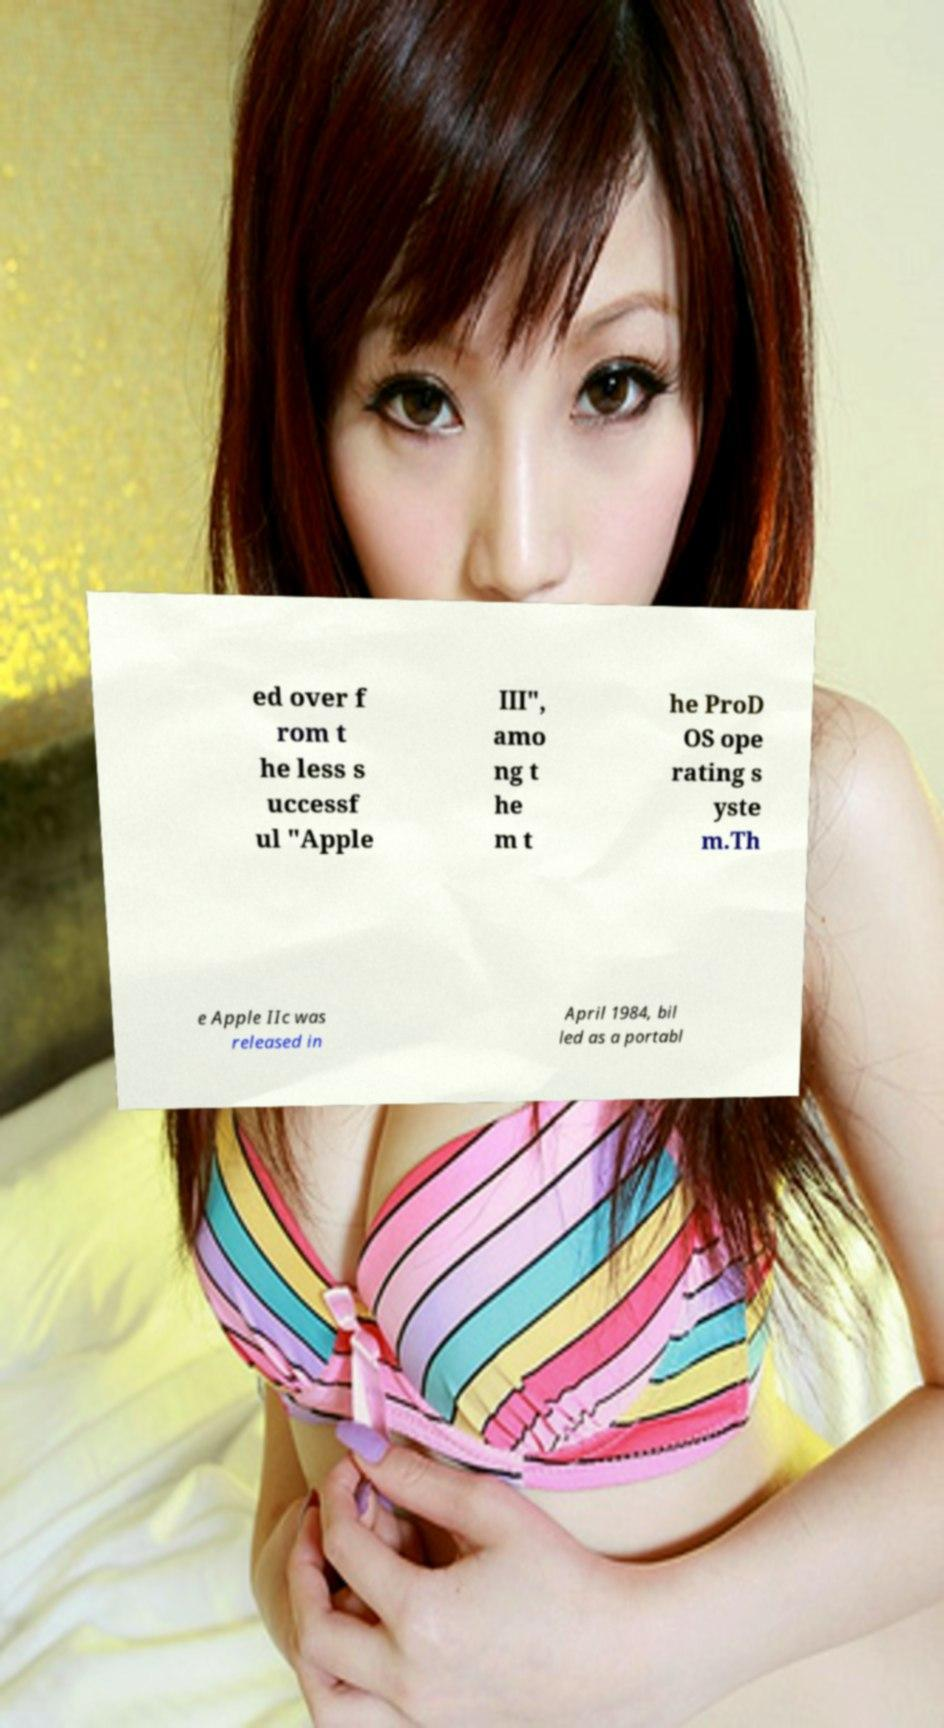Could you extract and type out the text from this image? ed over f rom t he less s uccessf ul "Apple III", amo ng t he m t he ProD OS ope rating s yste m.Th e Apple IIc was released in April 1984, bil led as a portabl 